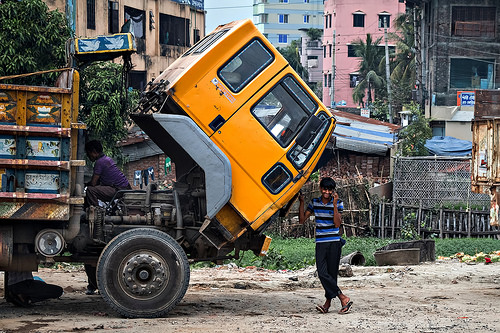<image>
Is there a man in the truck? No. The man is not contained within the truck. These objects have a different spatial relationship. Where is the person in relation to the truck? Is it in the truck? No. The person is not contained within the truck. These objects have a different spatial relationship. 